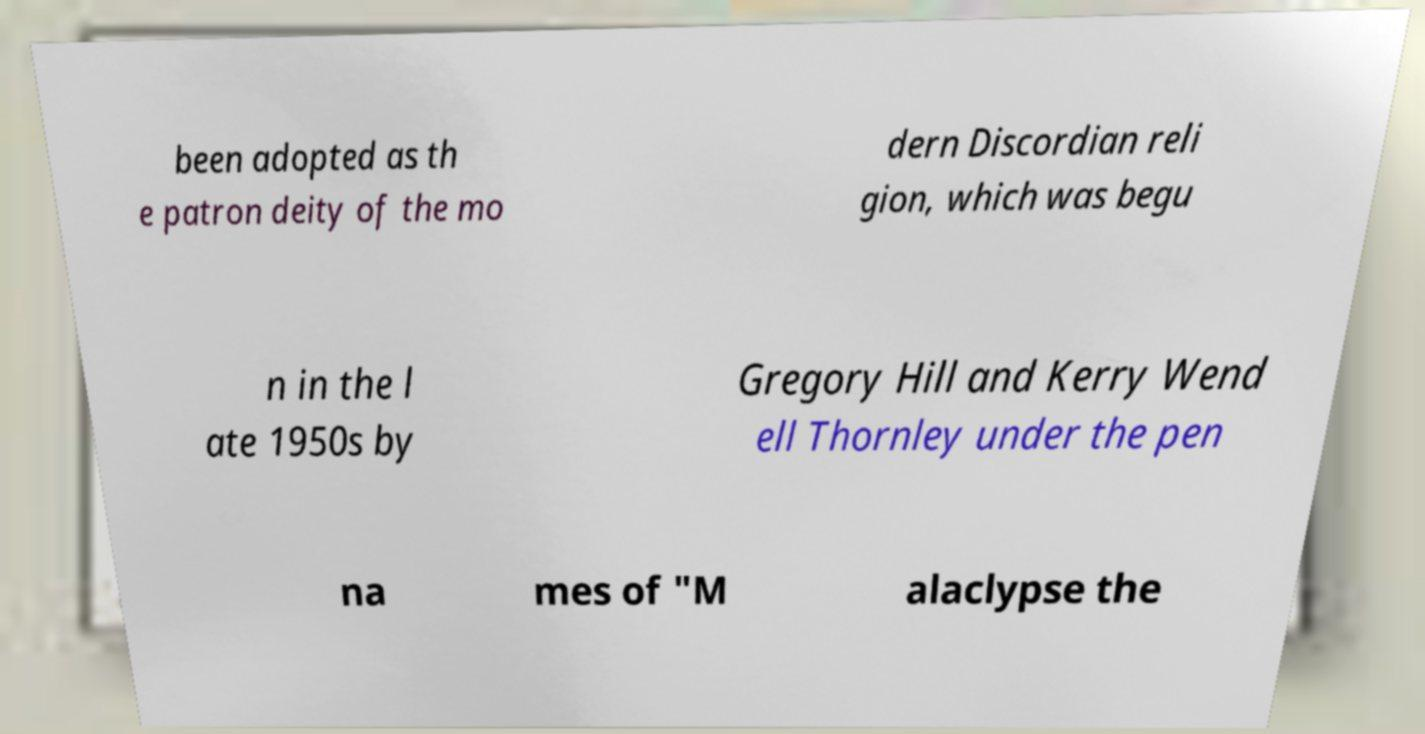What messages or text are displayed in this image? I need them in a readable, typed format. been adopted as th e patron deity of the mo dern Discordian reli gion, which was begu n in the l ate 1950s by Gregory Hill and Kerry Wend ell Thornley under the pen na mes of "M alaclypse the 